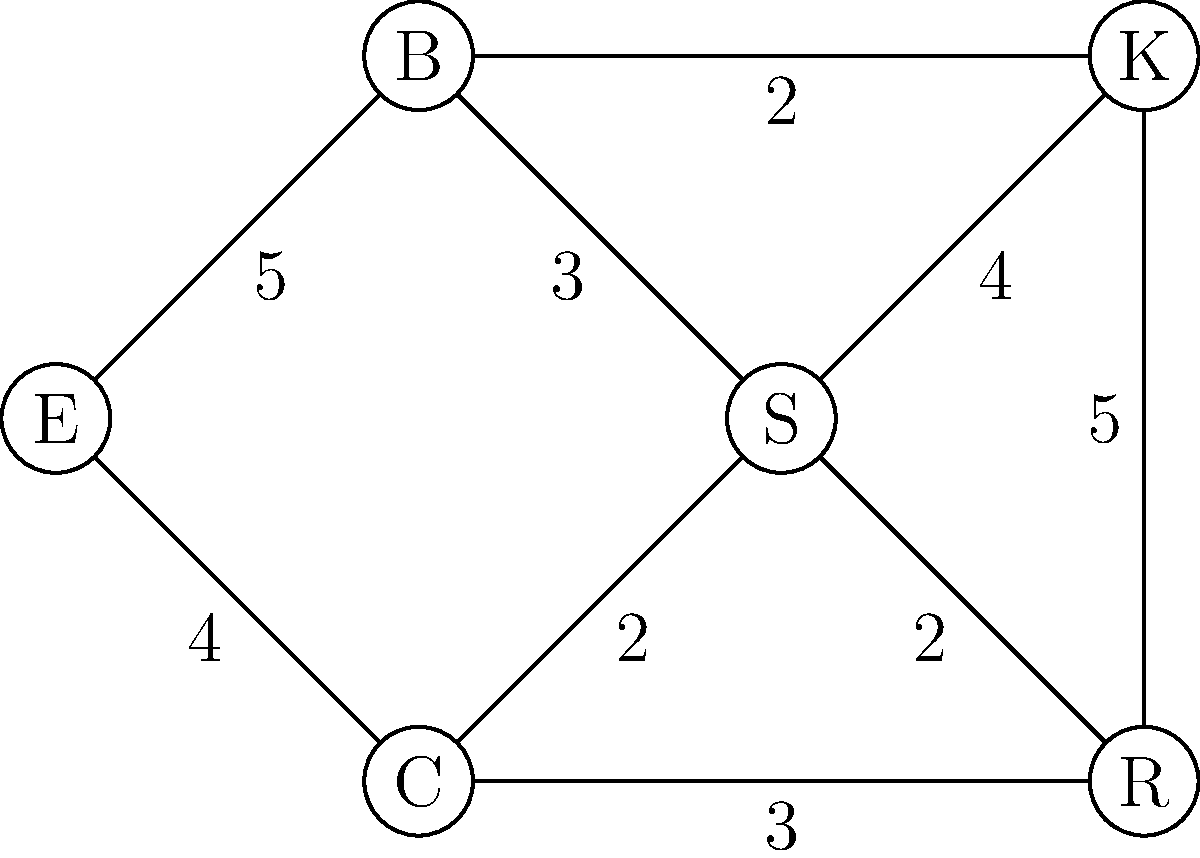In the network flow diagram of a coffee shop layout, nodes represent different areas (E: Entrance, B: Barista station, S: Seating area, C: Cashier, K: Kitchen, R: Restroom), and edge weights represent the maximum flow of customers per minute between areas. What is the maximum flow from the Entrance (E) to the Restroom (R), and which path(s) achieve this flow? To solve this problem, we'll use the Ford-Fulkerson algorithm to find the maximum flow from E to R:

1. Initialize flow to 0.
2. Find an augmenting path from E to R:
   Path 1: E → B → S → R (min capacity: 2)
   Increase flow by 2. Total flow = 2.

3. Find another augmenting path:
   Path 2: E → C → R (min capacity: 3)
   Increase flow by 3. Total flow = 5.

4. Find another augmenting path:
   Path 3: E → B → K → R (min capacity: 2)
   Increase flow by 2. Total flow = 7.

5. No more augmenting paths exist.

Therefore, the maximum flow from E to R is 7 customers per minute.

The paths that achieve this flow are:
1. E → B → S → R (2 customers/min)
2. E → C → R (3 customers/min)
3. E → B → K → R (2 customers/min)

This solution optimizes the customer flow from the entrance to the restroom, considering the capacity constraints of each area in the coffee shop.
Answer: Maximum flow: 7 customers/min. Paths: E→B→S→R, E→C→R, E→B→K→R. 